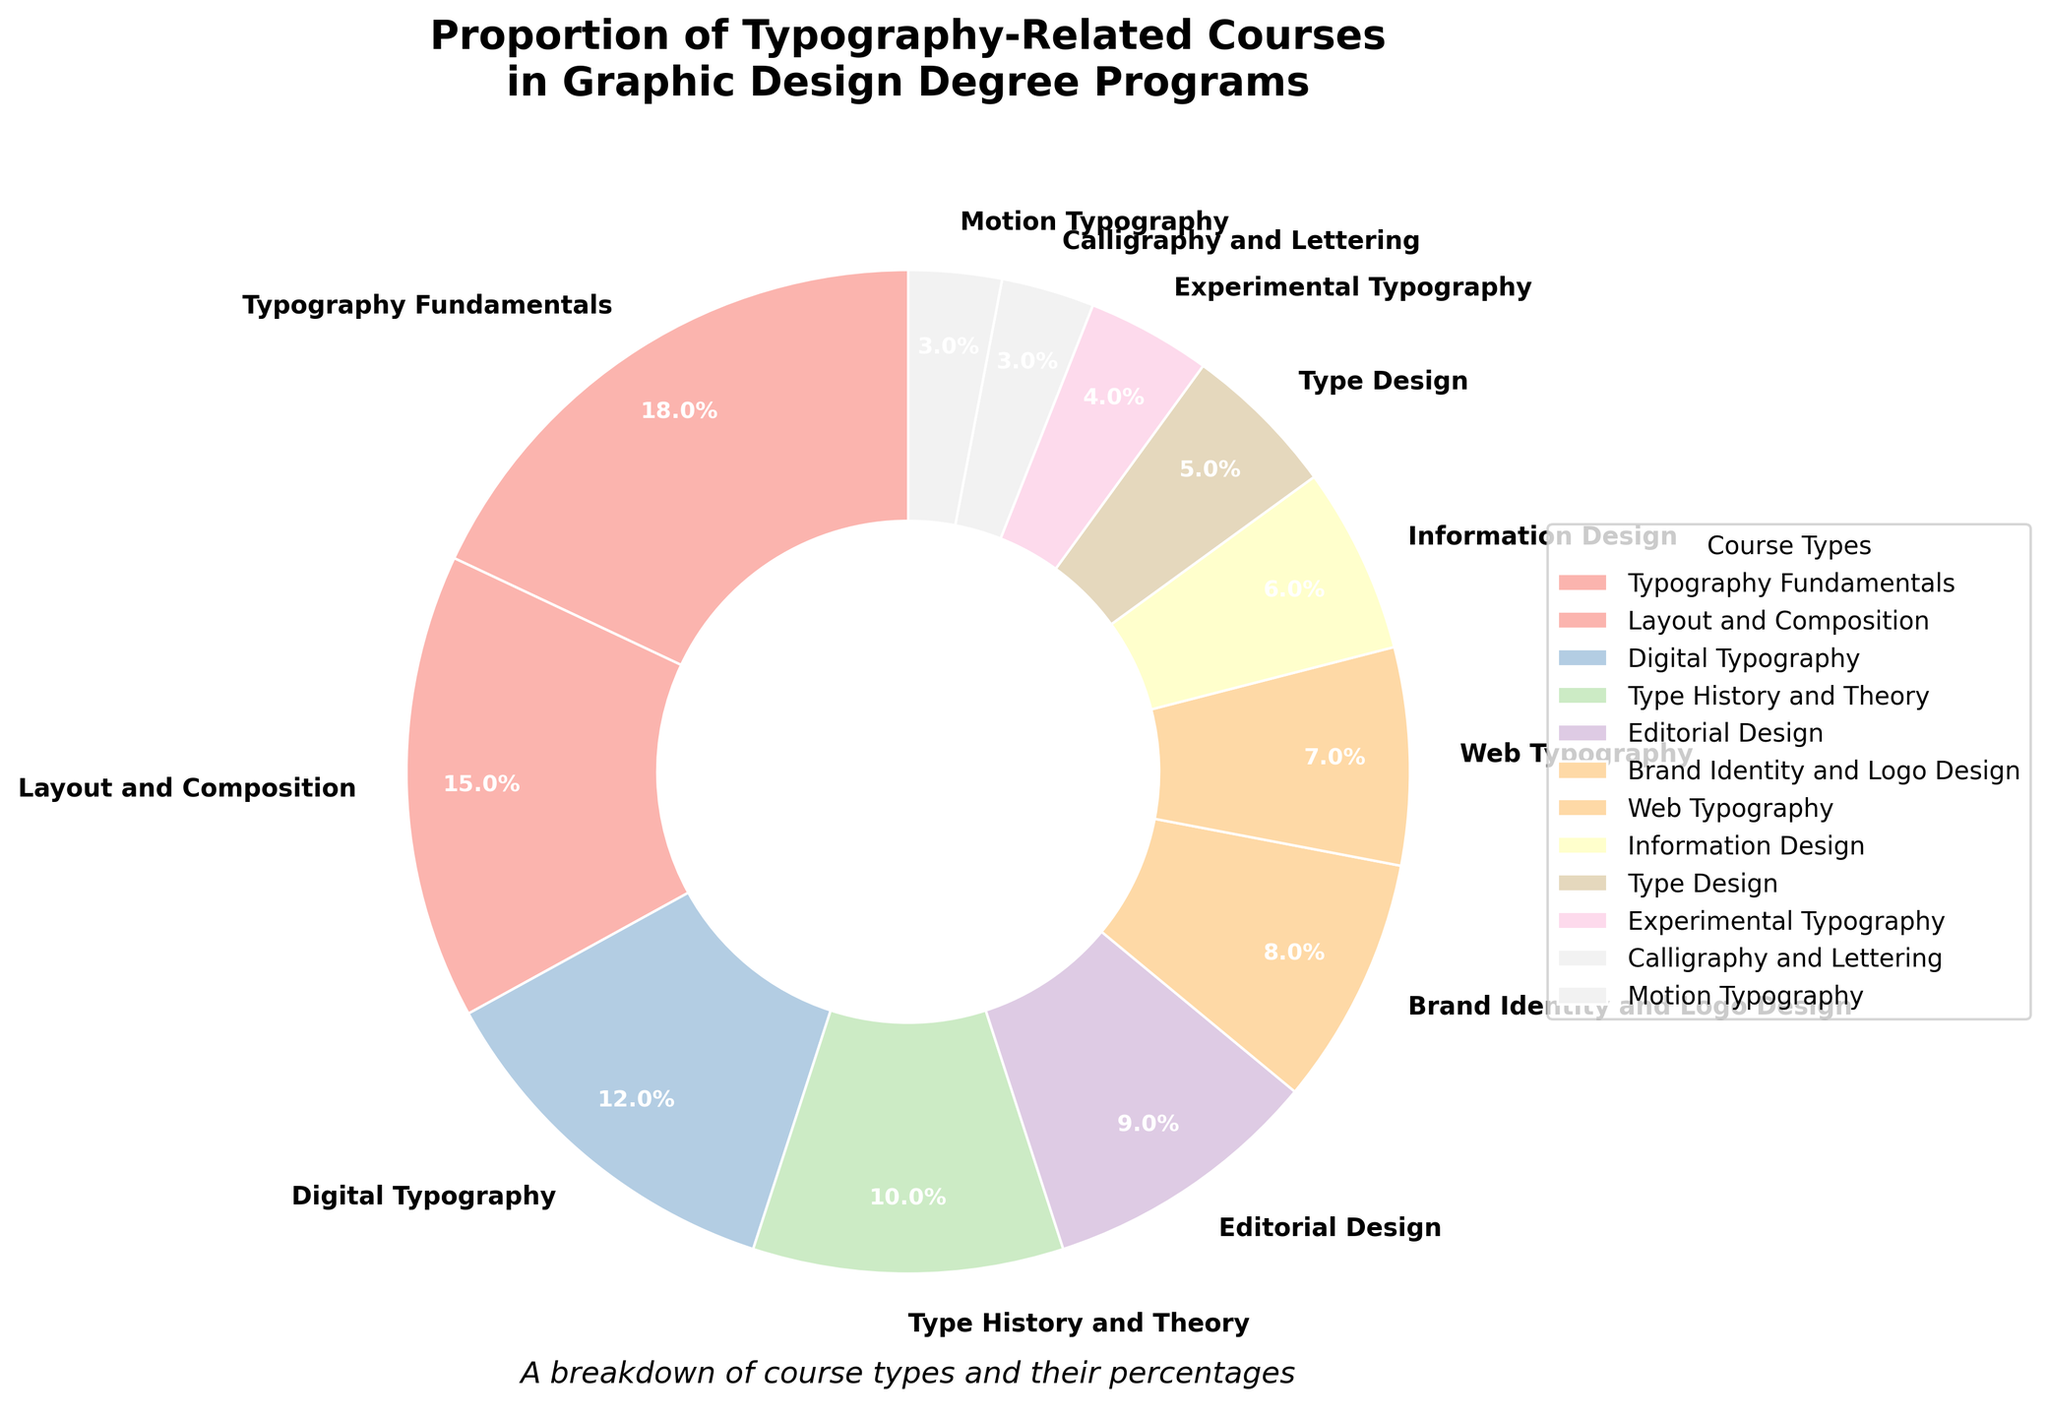Which course type has the highest proportion? Look at the pie chart and identify the label with the largest wedge. In this case, "Typography Fundamentals" occupies the largest segment.
Answer: Typography Fundamentals Which two courses together make up more than a quarter of the total courses? Sum the percentages of different course types and check which combinations exceed 25%. Here, 18% (Typography Fundamentals) + 12% (Digital Typography) = 30%, which is more than a quarter.
Answer: Typography Fundamentals and Digital Typography How much greater is the proportion of Layout and Composition compared to Motion Typography? Look at the pie chart and subtract the smaller percentage from the larger one: 15% (Layout and Composition) - 3% (Motion Typography) = 12%.
Answer: 12% What is the combined percentage of course types related to "Typography" (Typography Fundamentals, Digital Typography, Web Typography, Experimental Typography, Motion Typography)? Sum the percentages of all related course types: 18% (Typography Fundamentals) + 12% (Digital Typography) + 7% (Web Typography) + 4% (Experimental Typography) + 3% (Motion Typography) = 44%.
Answer: 44% Which course type has the smallest proportion, and what is its value? Look at the pie chart and find the label with the smallest wedge. In this case, "Calligraphy and Lettering" and "Motion Typography" both have the smallest proportion at 3%.
Answer: Calligraphy and Lettering and Motion Typography, 3% Are there more courses focused on typography or on design elements (Layout and Composition, Editorial Design, Brand Identity and Logo Design)? Compare the combined percentages of typography courses (Typography Fundamentals, Digital Typography, Web Typography, Experimental Typography, Motion Typography) with design elements. Typography courses: 18% + 12% + 7% + 4% + 3% = 44%. Design elements courses: 15% + 9% + 8% = 32%.
Answer: More on typography What is the difference in percentage between the highest and lowest proportion courses? Subtract the percentage of the smallest wedge from the largest one: 18% (Typography Fundamentals) - 3% (Motion Typography and Calligraphy and Lettering) = 15%.
Answer: 15% How many course types have a proportion equal to or greater than 10%? Identify and count the slices in the pie chart that are 10% or more. Typography Fundamentals (18%), Layout and Composition (15%), Digital Typography (12%), and Type History and Theory (10%) make 4 course types.
Answer: 4 What's the percentage difference between "Type Design" and "Information Design"? Subtract the percentage of the smaller wedge from the larger one: 6% (Information Design) - 5% (Type Design) = 1%.
Answer: 1% Which course type occupies the central position in terms of proportion and what is its percentage? Arrange courses in descending order of their percentage and find the middle one. The middle course in descending order is "Type History and Theory" with 10%.
Answer: Type History and Theory, 10% 